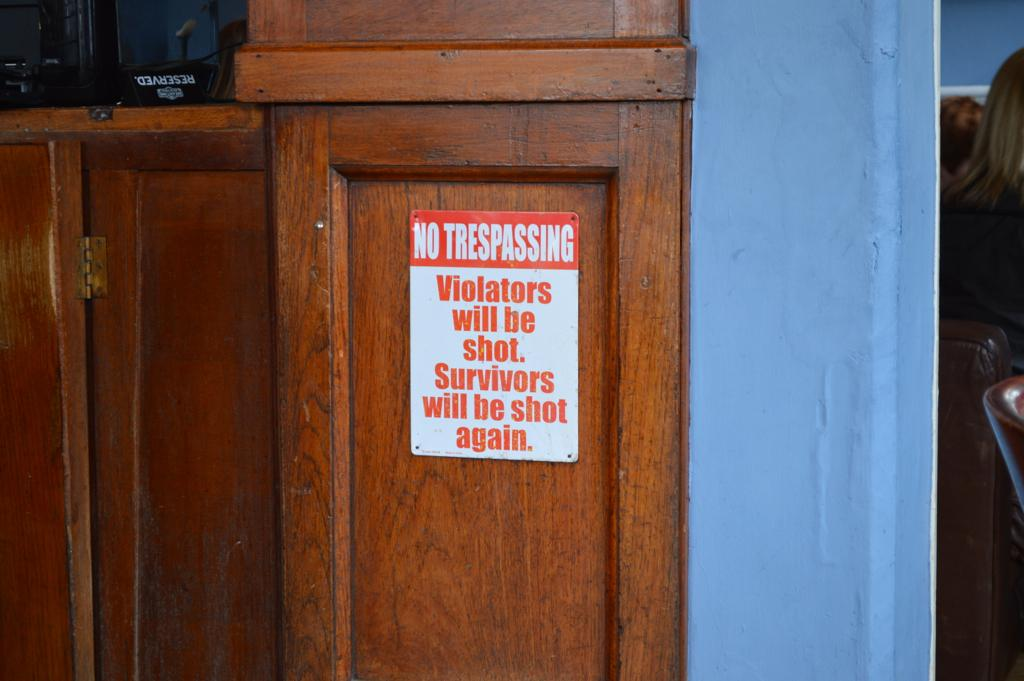What is located on the cupboard in the image? There is a poster on the cupboard in the image. Where is the poster positioned in relation to the image? The poster is in the center of the image. What can be seen on the right side of the image? There are people on the right side of the image. What type of potato is being transported by water in the image? There is no potato or water present in the image, so it cannot be determined if any potato is being transported by water. 